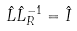<formula> <loc_0><loc_0><loc_500><loc_500>\hat { L } \hat { L } _ { R } ^ { - 1 } = \hat { I }</formula> 